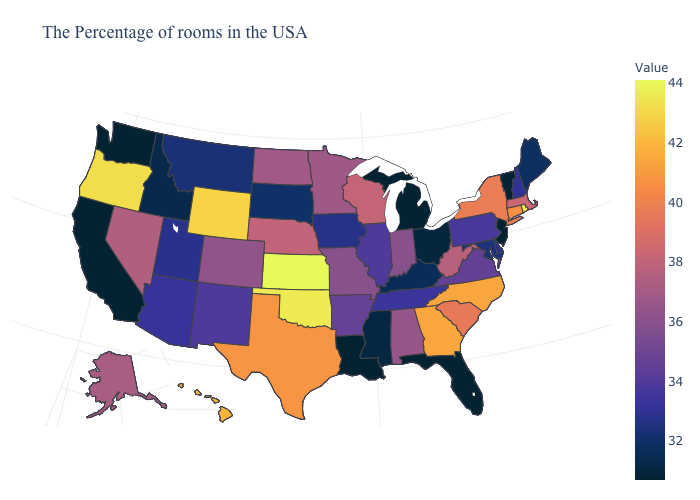Among the states that border West Virginia , does Ohio have the lowest value?
Be succinct. Yes. Does Maine have the highest value in the Northeast?
Keep it brief. No. Among the states that border New Mexico , which have the lowest value?
Quick response, please. Utah. Does Arizona have the highest value in the West?
Write a very short answer. No. Which states have the highest value in the USA?
Give a very brief answer. Kansas. Does Kansas have the highest value in the USA?
Keep it brief. Yes. 